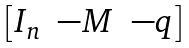<formula> <loc_0><loc_0><loc_500><loc_500>\begin{bmatrix} I _ { n } & - M & - q \end{bmatrix}</formula> 